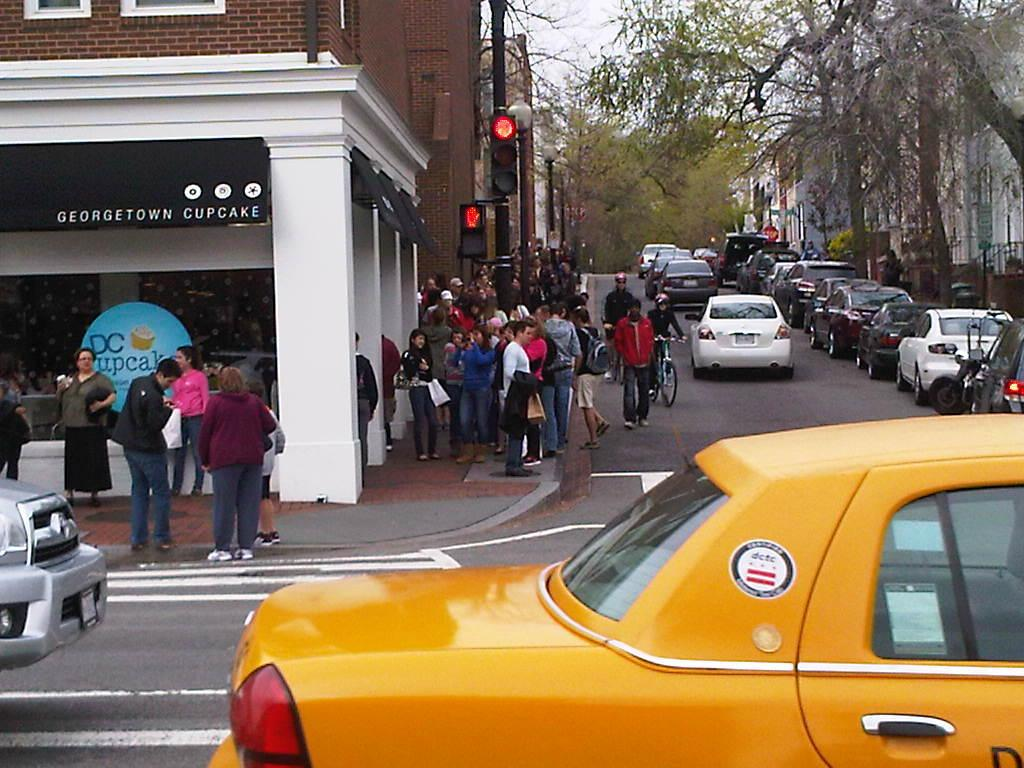<image>
Provide a brief description of the given image. People are standing outside the store Georgetown Cupcakes. 